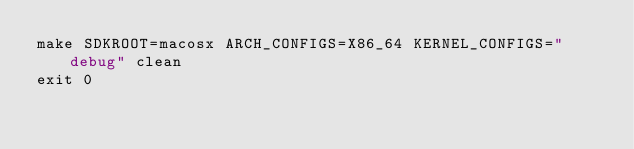<code> <loc_0><loc_0><loc_500><loc_500><_Bash_>make SDKROOT=macosx ARCH_CONFIGS=X86_64 KERNEL_CONFIGS="debug" clean
exit 0
</code> 